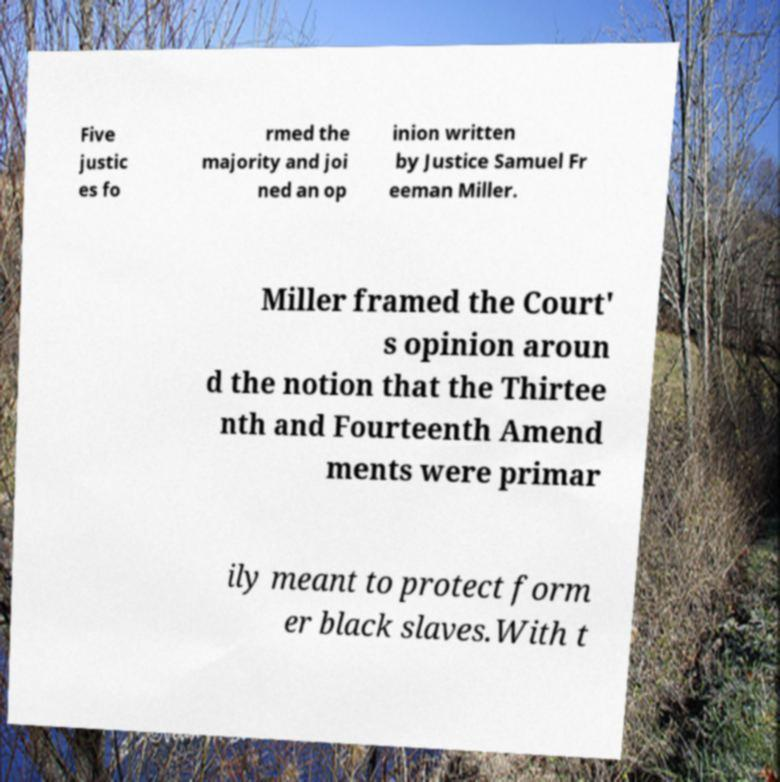Could you assist in decoding the text presented in this image and type it out clearly? Five justic es fo rmed the majority and joi ned an op inion written by Justice Samuel Fr eeman Miller. Miller framed the Court' s opinion aroun d the notion that the Thirtee nth and Fourteenth Amend ments were primar ily meant to protect form er black slaves.With t 